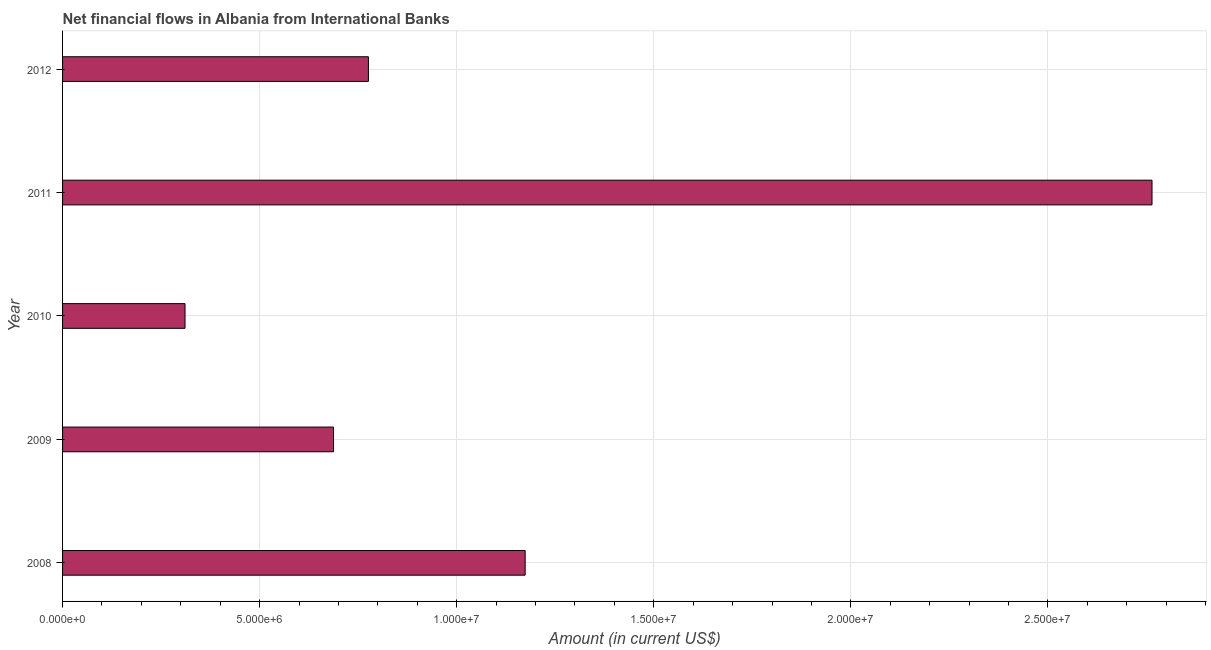What is the title of the graph?
Provide a succinct answer. Net financial flows in Albania from International Banks. What is the label or title of the X-axis?
Provide a short and direct response. Amount (in current US$). What is the net financial flows from ibrd in 2009?
Give a very brief answer. 6.87e+06. Across all years, what is the maximum net financial flows from ibrd?
Your answer should be very brief. 2.76e+07. Across all years, what is the minimum net financial flows from ibrd?
Your answer should be very brief. 3.11e+06. In which year was the net financial flows from ibrd maximum?
Offer a very short reply. 2011. In which year was the net financial flows from ibrd minimum?
Ensure brevity in your answer.  2010. What is the sum of the net financial flows from ibrd?
Offer a terse response. 5.71e+07. What is the difference between the net financial flows from ibrd in 2008 and 2012?
Offer a very short reply. 3.98e+06. What is the average net financial flows from ibrd per year?
Your answer should be very brief. 1.14e+07. What is the median net financial flows from ibrd?
Provide a short and direct response. 7.76e+06. In how many years, is the net financial flows from ibrd greater than 17000000 US$?
Keep it short and to the point. 1. Do a majority of the years between 2009 and 2011 (inclusive) have net financial flows from ibrd greater than 26000000 US$?
Your response must be concise. No. What is the ratio of the net financial flows from ibrd in 2008 to that in 2009?
Offer a terse response. 1.71. Is the difference between the net financial flows from ibrd in 2009 and 2012 greater than the difference between any two years?
Your answer should be very brief. No. What is the difference between the highest and the second highest net financial flows from ibrd?
Keep it short and to the point. 1.59e+07. What is the difference between the highest and the lowest net financial flows from ibrd?
Keep it short and to the point. 2.45e+07. In how many years, is the net financial flows from ibrd greater than the average net financial flows from ibrd taken over all years?
Provide a succinct answer. 2. How many years are there in the graph?
Keep it short and to the point. 5. What is the difference between two consecutive major ticks on the X-axis?
Provide a succinct answer. 5.00e+06. What is the Amount (in current US$) of 2008?
Provide a succinct answer. 1.17e+07. What is the Amount (in current US$) in 2009?
Offer a very short reply. 6.87e+06. What is the Amount (in current US$) in 2010?
Your answer should be very brief. 3.11e+06. What is the Amount (in current US$) of 2011?
Provide a short and direct response. 2.76e+07. What is the Amount (in current US$) of 2012?
Offer a terse response. 7.76e+06. What is the difference between the Amount (in current US$) in 2008 and 2009?
Offer a very short reply. 4.86e+06. What is the difference between the Amount (in current US$) in 2008 and 2010?
Offer a very short reply. 8.63e+06. What is the difference between the Amount (in current US$) in 2008 and 2011?
Offer a terse response. -1.59e+07. What is the difference between the Amount (in current US$) in 2008 and 2012?
Offer a terse response. 3.98e+06. What is the difference between the Amount (in current US$) in 2009 and 2010?
Provide a short and direct response. 3.77e+06. What is the difference between the Amount (in current US$) in 2009 and 2011?
Offer a very short reply. -2.08e+07. What is the difference between the Amount (in current US$) in 2009 and 2012?
Provide a short and direct response. -8.86e+05. What is the difference between the Amount (in current US$) in 2010 and 2011?
Offer a terse response. -2.45e+07. What is the difference between the Amount (in current US$) in 2010 and 2012?
Your answer should be compact. -4.65e+06. What is the difference between the Amount (in current US$) in 2011 and 2012?
Make the answer very short. 1.99e+07. What is the ratio of the Amount (in current US$) in 2008 to that in 2009?
Give a very brief answer. 1.71. What is the ratio of the Amount (in current US$) in 2008 to that in 2010?
Offer a very short reply. 3.78. What is the ratio of the Amount (in current US$) in 2008 to that in 2011?
Your answer should be very brief. 0.42. What is the ratio of the Amount (in current US$) in 2008 to that in 2012?
Keep it short and to the point. 1.51. What is the ratio of the Amount (in current US$) in 2009 to that in 2010?
Ensure brevity in your answer.  2.21. What is the ratio of the Amount (in current US$) in 2009 to that in 2011?
Your response must be concise. 0.25. What is the ratio of the Amount (in current US$) in 2009 to that in 2012?
Give a very brief answer. 0.89. What is the ratio of the Amount (in current US$) in 2010 to that in 2011?
Provide a short and direct response. 0.11. What is the ratio of the Amount (in current US$) in 2011 to that in 2012?
Provide a short and direct response. 3.56. 